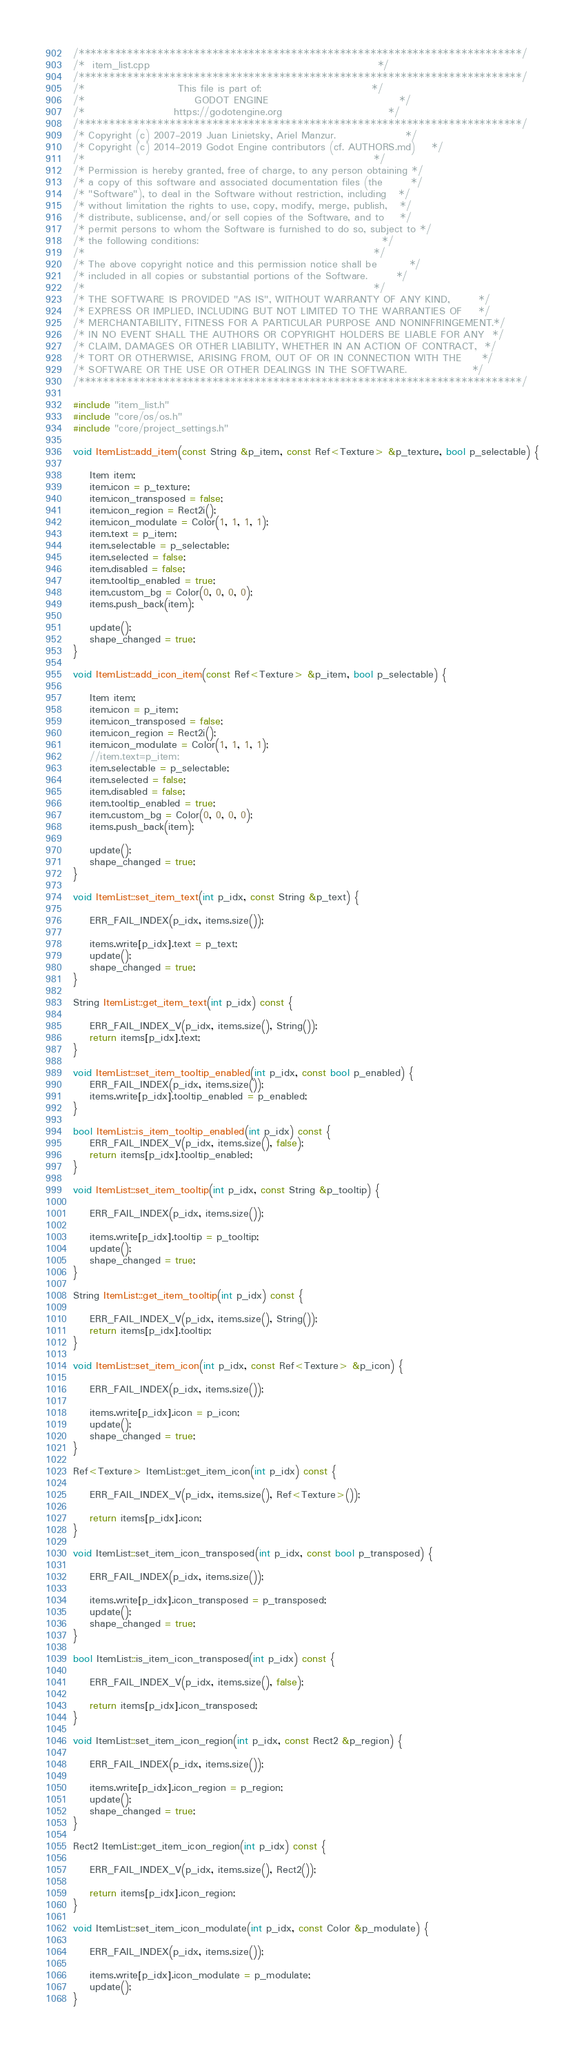Convert code to text. <code><loc_0><loc_0><loc_500><loc_500><_C++_>/*************************************************************************/
/*  item_list.cpp                                                        */
/*************************************************************************/
/*                       This file is part of:                           */
/*                           GODOT ENGINE                                */
/*                      https://godotengine.org                          */
/*************************************************************************/
/* Copyright (c) 2007-2019 Juan Linietsky, Ariel Manzur.                 */
/* Copyright (c) 2014-2019 Godot Engine contributors (cf. AUTHORS.md)    */
/*                                                                       */
/* Permission is hereby granted, free of charge, to any person obtaining */
/* a copy of this software and associated documentation files (the       */
/* "Software"), to deal in the Software without restriction, including   */
/* without limitation the rights to use, copy, modify, merge, publish,   */
/* distribute, sublicense, and/or sell copies of the Software, and to    */
/* permit persons to whom the Software is furnished to do so, subject to */
/* the following conditions:                                             */
/*                                                                       */
/* The above copyright notice and this permission notice shall be        */
/* included in all copies or substantial portions of the Software.       */
/*                                                                       */
/* THE SOFTWARE IS PROVIDED "AS IS", WITHOUT WARRANTY OF ANY KIND,       */
/* EXPRESS OR IMPLIED, INCLUDING BUT NOT LIMITED TO THE WARRANTIES OF    */
/* MERCHANTABILITY, FITNESS FOR A PARTICULAR PURPOSE AND NONINFRINGEMENT.*/
/* IN NO EVENT SHALL THE AUTHORS OR COPYRIGHT HOLDERS BE LIABLE FOR ANY  */
/* CLAIM, DAMAGES OR OTHER LIABILITY, WHETHER IN AN ACTION OF CONTRACT,  */
/* TORT OR OTHERWISE, ARISING FROM, OUT OF OR IN CONNECTION WITH THE     */
/* SOFTWARE OR THE USE OR OTHER DEALINGS IN THE SOFTWARE.                */
/*************************************************************************/

#include "item_list.h"
#include "core/os/os.h"
#include "core/project_settings.h"

void ItemList::add_item(const String &p_item, const Ref<Texture> &p_texture, bool p_selectable) {

	Item item;
	item.icon = p_texture;
	item.icon_transposed = false;
	item.icon_region = Rect2i();
	item.icon_modulate = Color(1, 1, 1, 1);
	item.text = p_item;
	item.selectable = p_selectable;
	item.selected = false;
	item.disabled = false;
	item.tooltip_enabled = true;
	item.custom_bg = Color(0, 0, 0, 0);
	items.push_back(item);

	update();
	shape_changed = true;
}

void ItemList::add_icon_item(const Ref<Texture> &p_item, bool p_selectable) {

	Item item;
	item.icon = p_item;
	item.icon_transposed = false;
	item.icon_region = Rect2i();
	item.icon_modulate = Color(1, 1, 1, 1);
	//item.text=p_item;
	item.selectable = p_selectable;
	item.selected = false;
	item.disabled = false;
	item.tooltip_enabled = true;
	item.custom_bg = Color(0, 0, 0, 0);
	items.push_back(item);

	update();
	shape_changed = true;
}

void ItemList::set_item_text(int p_idx, const String &p_text) {

	ERR_FAIL_INDEX(p_idx, items.size());

	items.write[p_idx].text = p_text;
	update();
	shape_changed = true;
}

String ItemList::get_item_text(int p_idx) const {

	ERR_FAIL_INDEX_V(p_idx, items.size(), String());
	return items[p_idx].text;
}

void ItemList::set_item_tooltip_enabled(int p_idx, const bool p_enabled) {
	ERR_FAIL_INDEX(p_idx, items.size());
	items.write[p_idx].tooltip_enabled = p_enabled;
}

bool ItemList::is_item_tooltip_enabled(int p_idx) const {
	ERR_FAIL_INDEX_V(p_idx, items.size(), false);
	return items[p_idx].tooltip_enabled;
}

void ItemList::set_item_tooltip(int p_idx, const String &p_tooltip) {

	ERR_FAIL_INDEX(p_idx, items.size());

	items.write[p_idx].tooltip = p_tooltip;
	update();
	shape_changed = true;
}

String ItemList::get_item_tooltip(int p_idx) const {

	ERR_FAIL_INDEX_V(p_idx, items.size(), String());
	return items[p_idx].tooltip;
}

void ItemList::set_item_icon(int p_idx, const Ref<Texture> &p_icon) {

	ERR_FAIL_INDEX(p_idx, items.size());

	items.write[p_idx].icon = p_icon;
	update();
	shape_changed = true;
}

Ref<Texture> ItemList::get_item_icon(int p_idx) const {

	ERR_FAIL_INDEX_V(p_idx, items.size(), Ref<Texture>());

	return items[p_idx].icon;
}

void ItemList::set_item_icon_transposed(int p_idx, const bool p_transposed) {

	ERR_FAIL_INDEX(p_idx, items.size());

	items.write[p_idx].icon_transposed = p_transposed;
	update();
	shape_changed = true;
}

bool ItemList::is_item_icon_transposed(int p_idx) const {

	ERR_FAIL_INDEX_V(p_idx, items.size(), false);

	return items[p_idx].icon_transposed;
}

void ItemList::set_item_icon_region(int p_idx, const Rect2 &p_region) {

	ERR_FAIL_INDEX(p_idx, items.size());

	items.write[p_idx].icon_region = p_region;
	update();
	shape_changed = true;
}

Rect2 ItemList::get_item_icon_region(int p_idx) const {

	ERR_FAIL_INDEX_V(p_idx, items.size(), Rect2());

	return items[p_idx].icon_region;
}

void ItemList::set_item_icon_modulate(int p_idx, const Color &p_modulate) {

	ERR_FAIL_INDEX(p_idx, items.size());

	items.write[p_idx].icon_modulate = p_modulate;
	update();
}
</code> 